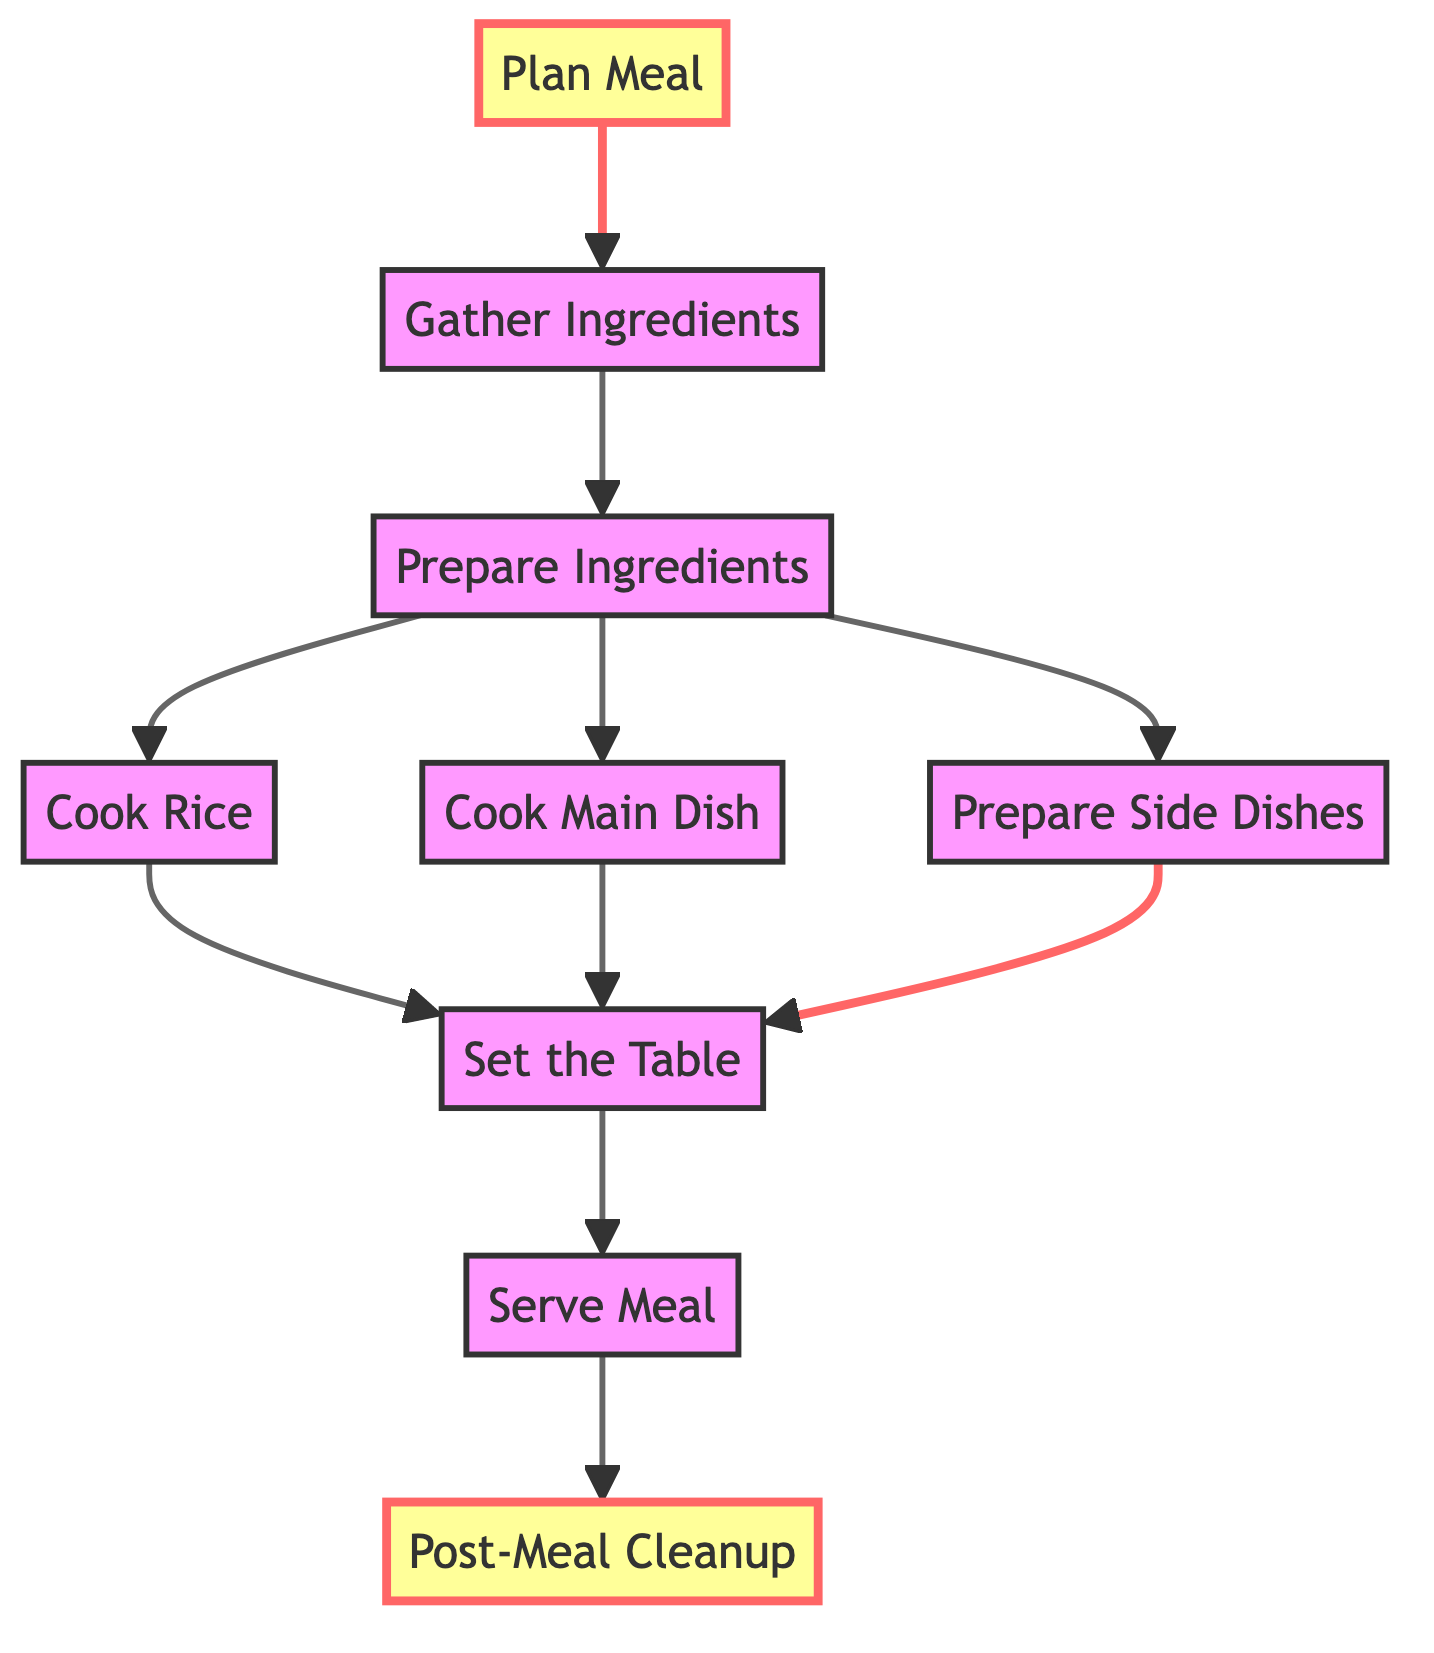What is the starting step in preparing traditional Filipino meals? The starting step is "Plan Meal," which is the first node in the flowchart and does not have any incoming connections. It initiates the process of preparing traditional Filipino meals.
Answer: Plan Meal How many main dishes can be cooked after preparing ingredients? After preparing ingredients, there are three options: "Cook Main Dish," "Cook Rice," and "Prepare Side Dishes." Hence, the total number of main dishes (including side dishes) that can be cooked is three.
Answer: 3 What step directly follows "Set the Table"? According to the flowchart, the step that directly follows "Set the Table" is "Serve Meal," which is the next node connected to "Set the Table."
Answer: Serve Meal Which step requires ingredients to be washed, chopped, and marinated? The step that requires ingredients to be washed, chopped, and marinated is "Prepare Ingredients." This node specifically describes these tasks as necessary preparations before cooking.
Answer: Prepare Ingredients What are the final actions taken after serving the meal? The final action taken after serving the meal is "Post-Meal Cleanup," which follows "Serve Meal" in the flowchart. This step indicates that cleanup is the last activity after the meal is served.
Answer: Post-Meal Cleanup What dish types can be prepared under "Cook Main Dish"? While the flowchart does not specify exact dishes under "Cook Main Dish," it indicates that dishes such as Adobo or Sinigang can be prepared in this step based on traditional Filipino cuisine.
Answer: Adobo or Sinigang Which step comes before "Set the Table"? The steps leading to "Set the Table" include "Cook Rice," "Cook Main Dish," and "Prepare Side Dishes." Since several steps connect to "Set the Table," you could say it can be preceded by any of these three steps.
Answer: Cook Rice, Cook Main Dish, Prepare Side Dishes What step is essential before serving the meal? Before serving the meal, it is essential to complete "Set the Table," which ensures that all the necessary utensils and plates are arranged properly for serving.
Answer: Set the Table 